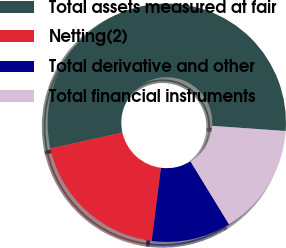Convert chart. <chart><loc_0><loc_0><loc_500><loc_500><pie_chart><fcel>Total assets measured at fair<fcel>Netting(2)<fcel>Total derivative and other<fcel>Total financial instruments<nl><fcel>54.58%<fcel>19.52%<fcel>10.76%<fcel>15.14%<nl></chart> 